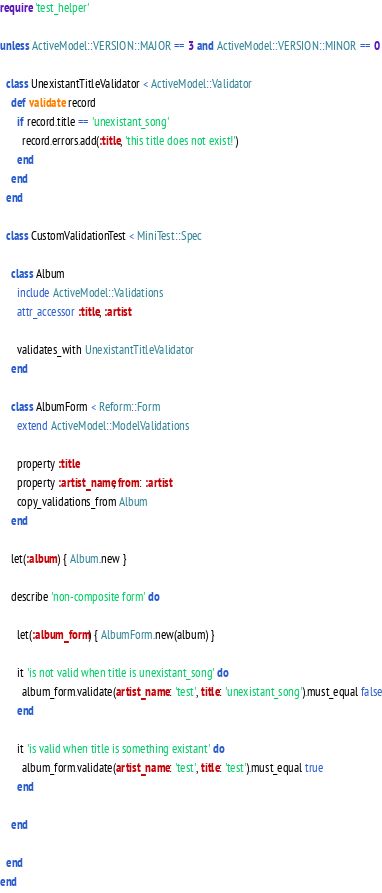Convert code to text. <code><loc_0><loc_0><loc_500><loc_500><_Ruby_>require 'test_helper'

unless ActiveModel::VERSION::MAJOR == 3 and ActiveModel::VERSION::MINOR == 0

  class UnexistantTitleValidator < ActiveModel::Validator
    def validate record
      if record.title == 'unexistant_song'
        record.errors.add(:title, 'this title does not exist!')
      end
    end
  end

  class CustomValidationTest < MiniTest::Spec

    class Album
      include ActiveModel::Validations
      attr_accessor :title, :artist

      validates_with UnexistantTitleValidator
    end

    class AlbumForm < Reform::Form
      extend ActiveModel::ModelValidations

      property :title
      property :artist_name, from: :artist
      copy_validations_from Album
    end

    let(:album) { Album.new }

    describe 'non-composite form' do

      let(:album_form) { AlbumForm.new(album) }

      it 'is not valid when title is unexistant_song' do
        album_form.validate(artist_name: 'test', title: 'unexistant_song').must_equal false
      end

      it 'is valid when title is something existant' do
        album_form.validate(artist_name: 'test', title: 'test').must_equal true
      end

    end

  end
end</code> 